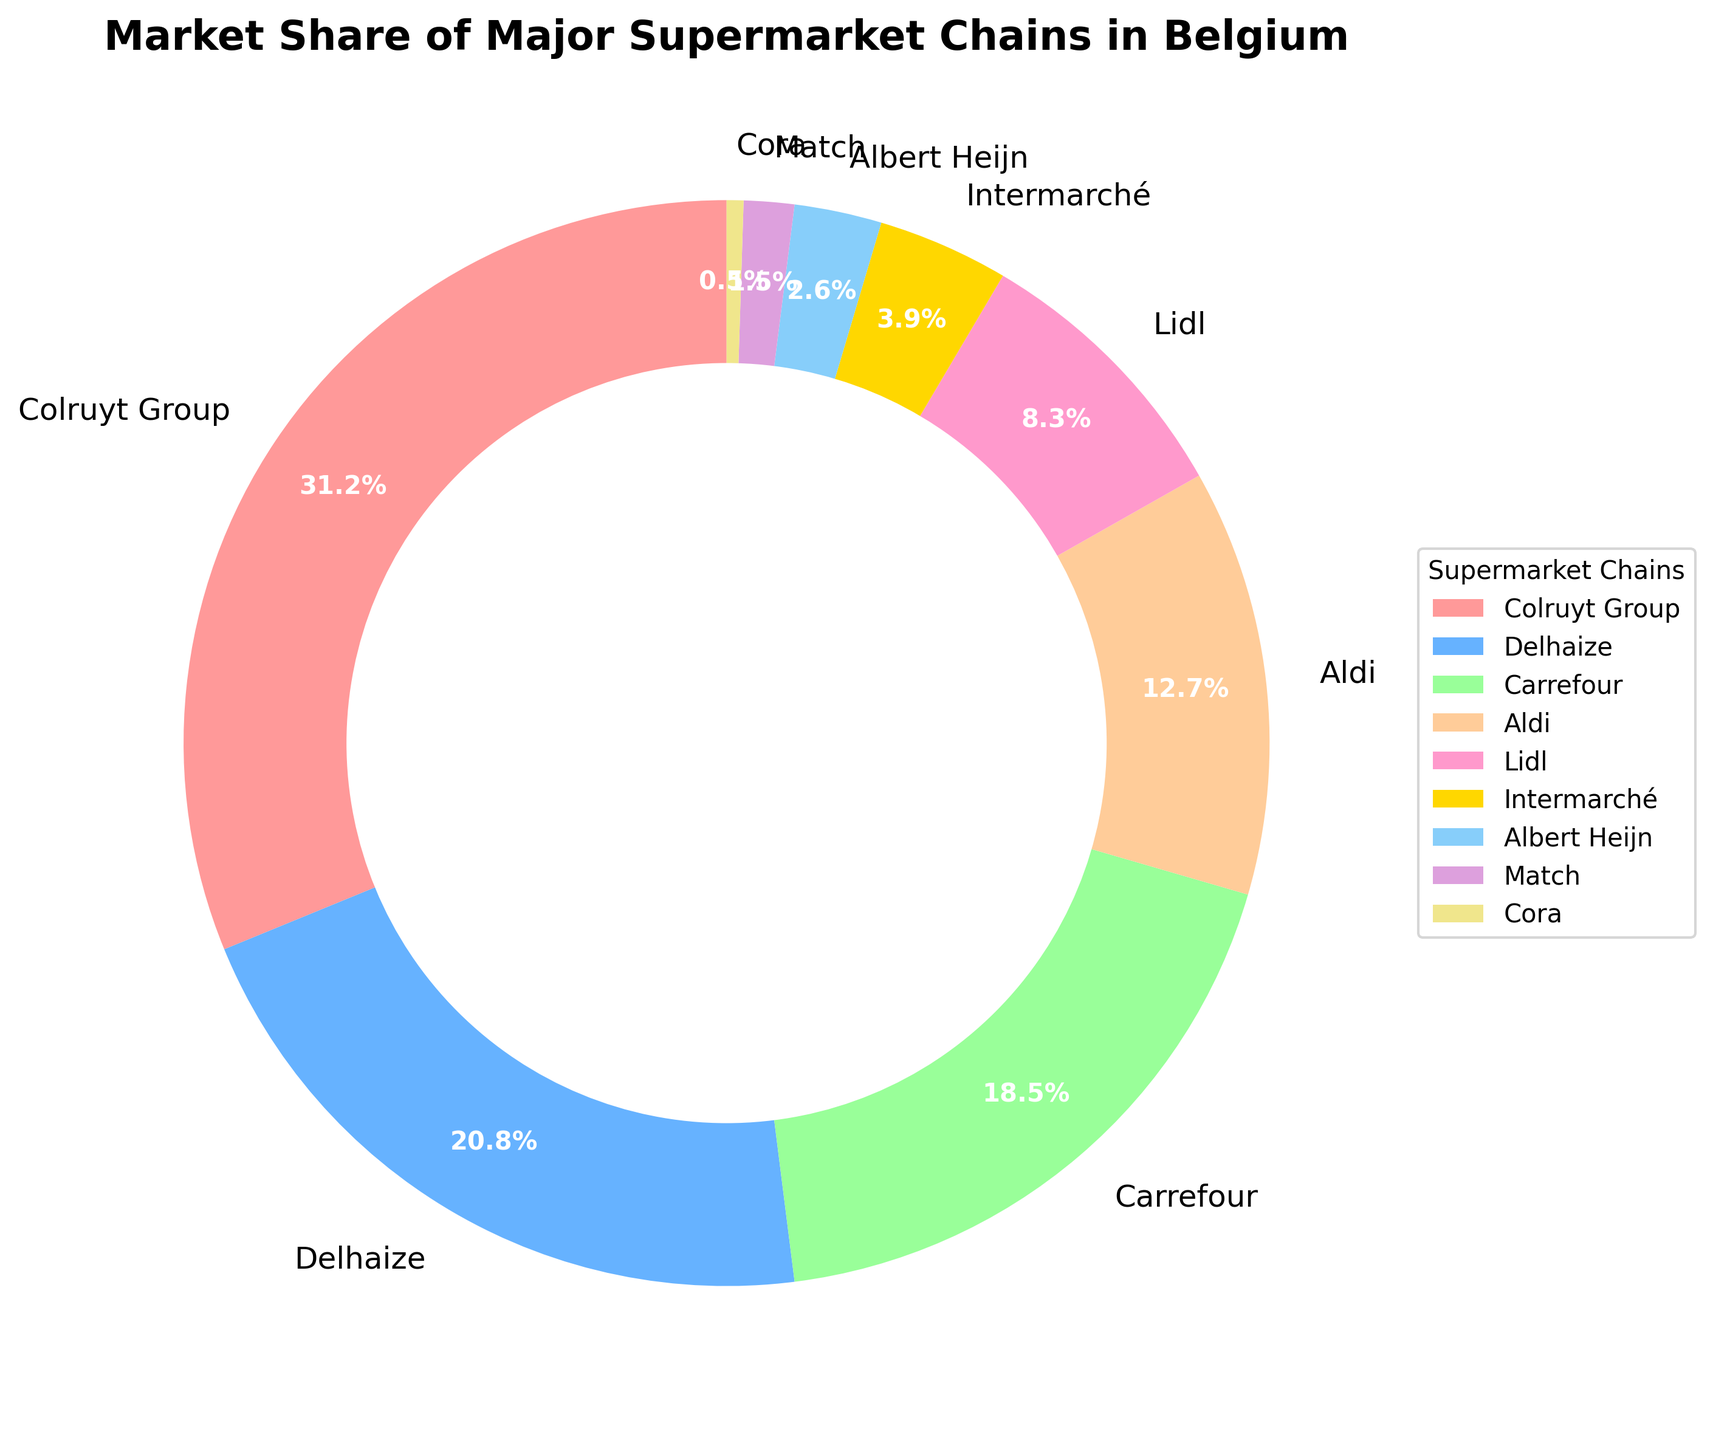Which supermarket chain has the largest market share? To determine which supermarket chain has the largest market share, look at the pie chart and identify the section with the largest proportional area. The label associated with this section will indicate the supermarket chain with the largest market share.
Answer: Colruyt Group What is the combined market share of Delhaize and Carrefour? To find the combined market share, identify the market share percentages for Delhaize and Carrefour from the pie chart. Add these percentages together: 20.8% (Delhaize) + 18.5% (Carrefour).
Answer: 39.3% Which supermarket chain has a smaller market share: Lidl or Aldi? To compare the market shares of Lidl and Aldi, locate the sections of the pie chart that represent these two supermarket chains and compare the sizes. Note the percentages: Lidl has 8.3%, and Aldi has 12.7%. Since 8.3% is smaller than 12.7%, Lidl has a smaller market share.
Answer: Lidl How many supermarket chains have a market share greater than 10%? To answer this, look at the pie chart and identify which sections represent a market share greater than 10%. Count these sections: Colruyt Group (31.2%), Delhaize (20.8%), Carrefour (18.5%), and Aldi (12.7%). The total is 4 chains.
Answer: 4 What is the difference in market share between Albert Heijn and Match? Find the market share values for Albert Heijn (2.6%) and Match (1.5%) from the pie chart. Subtract the smaller value from the larger value to get the difference: 2.6% - 1.5%.
Answer: 1.1% Which supermarket chain has a market share closest to 4%? To find the supermarket chain with a market share closest to 4%, look for percentages near this value in the pie chart. Intermarché has a market share of 3.9%, which is the closest to 4%.
Answer: Intermarché If Carrefour's market share increased by 5%, what would its new market share be? Start with Carrefour's current market share of 18.5%, then add 5% to it. The new market share would be 18.5% + 5%.
Answer: 23.5% What is the approximate market share difference between the largest and the smallest supermarket chain? To find the difference, identify the largest market share (Colruyt Group at 31.2%) and the smallest market share (Cora at 0.5%) from the pie chart. Subtract the smallest from the largest: 31.2% - 0.5%.
Answer: 30.7% If the market share of Lidl combined with Intermarché, would it surpass Carrefour? Combine the market share percentages of Lidl (8.3%) and Intermarché (3.9%). Compare the sum to Carrefour's market share. 8.3% + 3.9% = 12.2%, which is less than 18.5% (Carrefour's market share).
Answer: No Which section of the pie chart is represented by the color closest to gold? Identify the section of the pie chart that is colored in a gold-like shade. The corresponding label associated with this section will indicate the supermarket chain. The section colored gold represents Albert Heijn.
Answer: Albert Heijn 